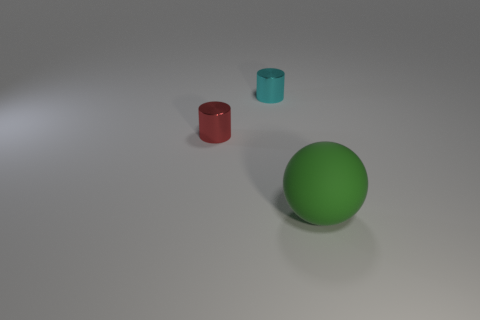Does the arrangement of objects suggest any particular theme or purpose? The objects do not seem to convey an intentional theme or purpose; they are placed randomly and could be part of a color or shape recognition study. 